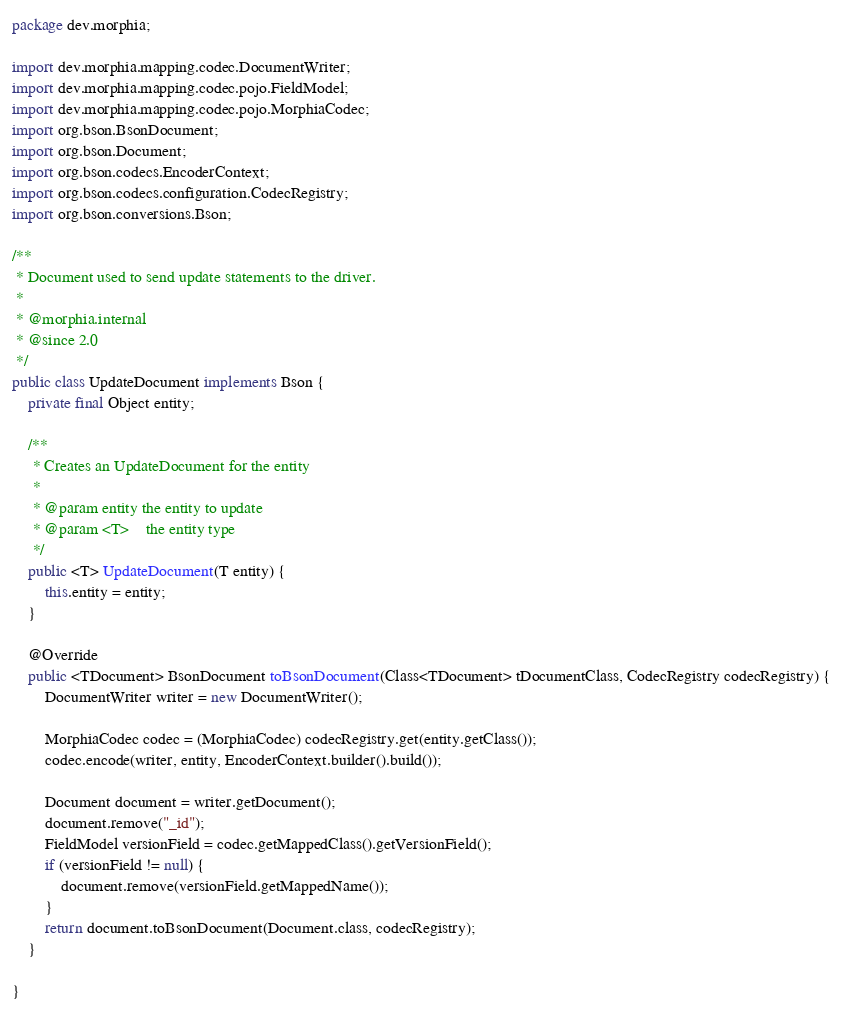<code> <loc_0><loc_0><loc_500><loc_500><_Java_>package dev.morphia;

import dev.morphia.mapping.codec.DocumentWriter;
import dev.morphia.mapping.codec.pojo.FieldModel;
import dev.morphia.mapping.codec.pojo.MorphiaCodec;
import org.bson.BsonDocument;
import org.bson.Document;
import org.bson.codecs.EncoderContext;
import org.bson.codecs.configuration.CodecRegistry;
import org.bson.conversions.Bson;

/**
 * Document used to send update statements to the driver.
 *
 * @morphia.internal
 * @since 2.0
 */
public class UpdateDocument implements Bson {
    private final Object entity;

    /**
     * Creates an UpdateDocument for the entity
     *
     * @param entity the entity to update
     * @param <T>    the entity type
     */
    public <T> UpdateDocument(T entity) {
        this.entity = entity;
    }

    @Override
    public <TDocument> BsonDocument toBsonDocument(Class<TDocument> tDocumentClass, CodecRegistry codecRegistry) {
        DocumentWriter writer = new DocumentWriter();

        MorphiaCodec codec = (MorphiaCodec) codecRegistry.get(entity.getClass());
        codec.encode(writer, entity, EncoderContext.builder().build());

        Document document = writer.getDocument();
        document.remove("_id");
        FieldModel versionField = codec.getMappedClass().getVersionField();
        if (versionField != null) {
            document.remove(versionField.getMappedName());
        }
        return document.toBsonDocument(Document.class, codecRegistry);
    }

}
</code> 